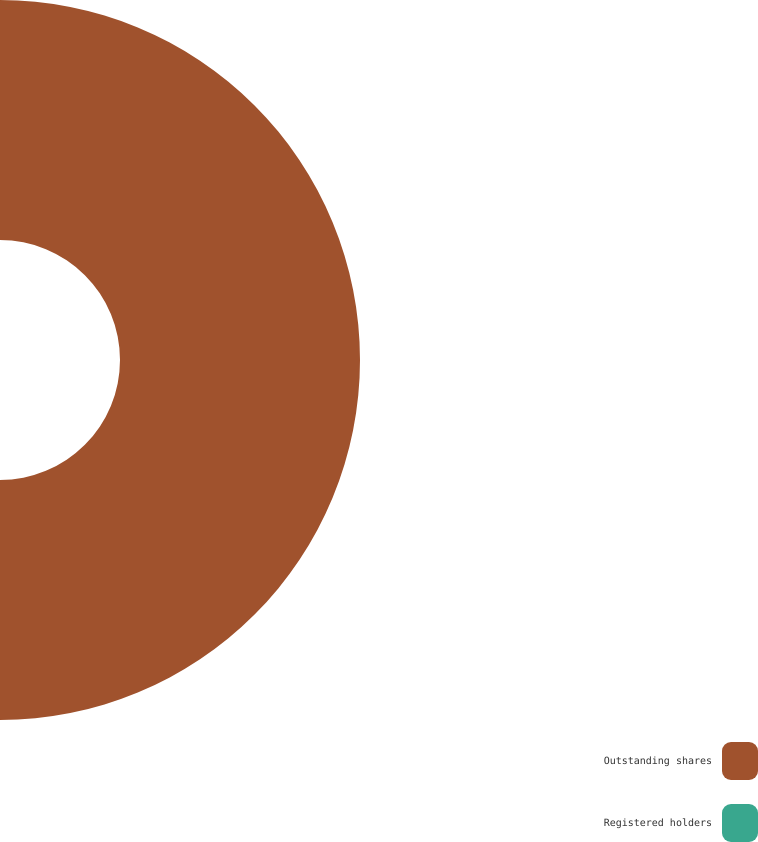<chart> <loc_0><loc_0><loc_500><loc_500><pie_chart><fcel>Outstanding shares<fcel>Registered holders<nl><fcel>100.0%<fcel>0.0%<nl></chart> 